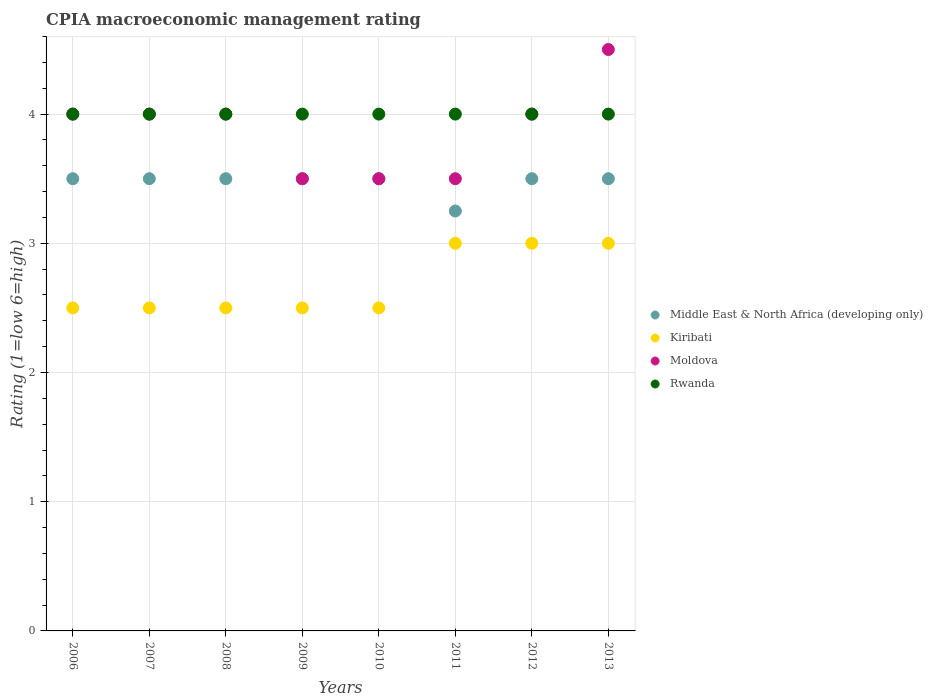How many different coloured dotlines are there?
Provide a short and direct response. 4. Is the number of dotlines equal to the number of legend labels?
Your response must be concise. Yes. What is the CPIA rating in Rwanda in 2010?
Your answer should be compact. 4. Across all years, what is the minimum CPIA rating in Moldova?
Your response must be concise. 3.5. What is the difference between the CPIA rating in Rwanda in 2006 and that in 2009?
Make the answer very short. 0. What is the average CPIA rating in Moldova per year?
Provide a succinct answer. 3.88. In the year 2010, what is the difference between the CPIA rating in Middle East & North Africa (developing only) and CPIA rating in Kiribati?
Your answer should be compact. 1. In how many years, is the CPIA rating in Middle East & North Africa (developing only) greater than 3.4?
Make the answer very short. 7. What is the ratio of the CPIA rating in Moldova in 2009 to that in 2013?
Offer a very short reply. 0.78. Is the CPIA rating in Moldova in 2006 less than that in 2009?
Your answer should be compact. No. What is the difference between the highest and the lowest CPIA rating in Rwanda?
Offer a very short reply. 0. In how many years, is the CPIA rating in Kiribati greater than the average CPIA rating in Kiribati taken over all years?
Make the answer very short. 3. Is the sum of the CPIA rating in Kiribati in 2008 and 2011 greater than the maximum CPIA rating in Moldova across all years?
Give a very brief answer. Yes. Is it the case that in every year, the sum of the CPIA rating in Middle East & North Africa (developing only) and CPIA rating in Kiribati  is greater than the sum of CPIA rating in Rwanda and CPIA rating in Moldova?
Ensure brevity in your answer.  Yes. Does the CPIA rating in Middle East & North Africa (developing only) monotonically increase over the years?
Ensure brevity in your answer.  No. Is the CPIA rating in Rwanda strictly greater than the CPIA rating in Moldova over the years?
Ensure brevity in your answer.  No. What is the difference between two consecutive major ticks on the Y-axis?
Keep it short and to the point. 1. Are the values on the major ticks of Y-axis written in scientific E-notation?
Provide a succinct answer. No. Does the graph contain any zero values?
Your response must be concise. No. Where does the legend appear in the graph?
Your answer should be very brief. Center right. How many legend labels are there?
Offer a terse response. 4. How are the legend labels stacked?
Provide a short and direct response. Vertical. What is the title of the graph?
Offer a terse response. CPIA macroeconomic management rating. Does "Uganda" appear as one of the legend labels in the graph?
Your answer should be very brief. No. What is the label or title of the X-axis?
Offer a very short reply. Years. What is the Rating (1=low 6=high) in Middle East & North Africa (developing only) in 2006?
Provide a succinct answer. 3.5. What is the Rating (1=low 6=high) in Rwanda in 2006?
Keep it short and to the point. 4. What is the Rating (1=low 6=high) of Middle East & North Africa (developing only) in 2007?
Ensure brevity in your answer.  3.5. What is the Rating (1=low 6=high) of Kiribati in 2007?
Your response must be concise. 2.5. What is the Rating (1=low 6=high) of Moldova in 2007?
Offer a very short reply. 4. What is the Rating (1=low 6=high) in Middle East & North Africa (developing only) in 2008?
Your answer should be very brief. 3.5. What is the Rating (1=low 6=high) in Kiribati in 2008?
Provide a short and direct response. 2.5. What is the Rating (1=low 6=high) of Kiribati in 2009?
Give a very brief answer. 2.5. What is the Rating (1=low 6=high) of Kiribati in 2010?
Provide a succinct answer. 2.5. What is the Rating (1=low 6=high) of Rwanda in 2010?
Give a very brief answer. 4. What is the Rating (1=low 6=high) of Moldova in 2011?
Your response must be concise. 3.5. What is the Rating (1=low 6=high) of Rwanda in 2011?
Your answer should be compact. 4. What is the Rating (1=low 6=high) of Rwanda in 2012?
Provide a short and direct response. 4. What is the Rating (1=low 6=high) of Rwanda in 2013?
Your response must be concise. 4. Across all years, what is the maximum Rating (1=low 6=high) of Kiribati?
Provide a short and direct response. 3. Across all years, what is the minimum Rating (1=low 6=high) of Middle East & North Africa (developing only)?
Provide a succinct answer. 3.25. Across all years, what is the minimum Rating (1=low 6=high) in Rwanda?
Ensure brevity in your answer.  4. What is the total Rating (1=low 6=high) in Middle East & North Africa (developing only) in the graph?
Provide a short and direct response. 27.75. What is the total Rating (1=low 6=high) in Kiribati in the graph?
Your response must be concise. 21.5. What is the total Rating (1=low 6=high) of Rwanda in the graph?
Provide a short and direct response. 32. What is the difference between the Rating (1=low 6=high) in Middle East & North Africa (developing only) in 2006 and that in 2007?
Offer a terse response. 0. What is the difference between the Rating (1=low 6=high) in Middle East & North Africa (developing only) in 2006 and that in 2008?
Offer a very short reply. 0. What is the difference between the Rating (1=low 6=high) in Moldova in 2006 and that in 2008?
Give a very brief answer. 0. What is the difference between the Rating (1=low 6=high) in Rwanda in 2006 and that in 2008?
Give a very brief answer. 0. What is the difference between the Rating (1=low 6=high) of Middle East & North Africa (developing only) in 2006 and that in 2009?
Offer a very short reply. 0. What is the difference between the Rating (1=low 6=high) in Moldova in 2006 and that in 2009?
Provide a succinct answer. 0.5. What is the difference between the Rating (1=low 6=high) of Rwanda in 2006 and that in 2009?
Offer a very short reply. 0. What is the difference between the Rating (1=low 6=high) of Middle East & North Africa (developing only) in 2006 and that in 2010?
Offer a very short reply. 0. What is the difference between the Rating (1=low 6=high) of Kiribati in 2006 and that in 2010?
Offer a terse response. 0. What is the difference between the Rating (1=low 6=high) in Rwanda in 2006 and that in 2010?
Provide a short and direct response. 0. What is the difference between the Rating (1=low 6=high) of Moldova in 2006 and that in 2011?
Offer a terse response. 0.5. What is the difference between the Rating (1=low 6=high) of Rwanda in 2006 and that in 2011?
Provide a succinct answer. 0. What is the difference between the Rating (1=low 6=high) in Middle East & North Africa (developing only) in 2006 and that in 2013?
Provide a succinct answer. 0. What is the difference between the Rating (1=low 6=high) in Kiribati in 2006 and that in 2013?
Ensure brevity in your answer.  -0.5. What is the difference between the Rating (1=low 6=high) of Moldova in 2006 and that in 2013?
Give a very brief answer. -0.5. What is the difference between the Rating (1=low 6=high) of Rwanda in 2006 and that in 2013?
Offer a terse response. 0. What is the difference between the Rating (1=low 6=high) of Rwanda in 2007 and that in 2008?
Offer a very short reply. 0. What is the difference between the Rating (1=low 6=high) in Kiribati in 2007 and that in 2009?
Provide a succinct answer. 0. What is the difference between the Rating (1=low 6=high) of Moldova in 2007 and that in 2009?
Offer a terse response. 0.5. What is the difference between the Rating (1=low 6=high) in Rwanda in 2007 and that in 2009?
Your response must be concise. 0. What is the difference between the Rating (1=low 6=high) of Middle East & North Africa (developing only) in 2007 and that in 2010?
Ensure brevity in your answer.  0. What is the difference between the Rating (1=low 6=high) of Kiribati in 2007 and that in 2010?
Give a very brief answer. 0. What is the difference between the Rating (1=low 6=high) of Moldova in 2007 and that in 2011?
Your answer should be very brief. 0.5. What is the difference between the Rating (1=low 6=high) in Kiribati in 2007 and that in 2012?
Offer a very short reply. -0.5. What is the difference between the Rating (1=low 6=high) in Rwanda in 2007 and that in 2012?
Give a very brief answer. 0. What is the difference between the Rating (1=low 6=high) in Rwanda in 2007 and that in 2013?
Offer a terse response. 0. What is the difference between the Rating (1=low 6=high) of Middle East & North Africa (developing only) in 2008 and that in 2009?
Your response must be concise. 0. What is the difference between the Rating (1=low 6=high) in Moldova in 2008 and that in 2009?
Your answer should be very brief. 0.5. What is the difference between the Rating (1=low 6=high) of Kiribati in 2008 and that in 2010?
Your response must be concise. 0. What is the difference between the Rating (1=low 6=high) in Middle East & North Africa (developing only) in 2008 and that in 2011?
Offer a terse response. 0.25. What is the difference between the Rating (1=low 6=high) in Kiribati in 2008 and that in 2011?
Provide a succinct answer. -0.5. What is the difference between the Rating (1=low 6=high) of Middle East & North Africa (developing only) in 2008 and that in 2012?
Provide a short and direct response. 0. What is the difference between the Rating (1=low 6=high) in Kiribati in 2008 and that in 2013?
Offer a very short reply. -0.5. What is the difference between the Rating (1=low 6=high) in Moldova in 2008 and that in 2013?
Your answer should be very brief. -0.5. What is the difference between the Rating (1=low 6=high) in Moldova in 2009 and that in 2011?
Give a very brief answer. 0. What is the difference between the Rating (1=low 6=high) of Middle East & North Africa (developing only) in 2009 and that in 2012?
Your answer should be compact. 0. What is the difference between the Rating (1=low 6=high) of Moldova in 2009 and that in 2012?
Provide a short and direct response. -0.5. What is the difference between the Rating (1=low 6=high) of Kiribati in 2009 and that in 2013?
Ensure brevity in your answer.  -0.5. What is the difference between the Rating (1=low 6=high) in Moldova in 2009 and that in 2013?
Offer a terse response. -1. What is the difference between the Rating (1=low 6=high) of Rwanda in 2009 and that in 2013?
Keep it short and to the point. 0. What is the difference between the Rating (1=low 6=high) in Kiribati in 2010 and that in 2011?
Give a very brief answer. -0.5. What is the difference between the Rating (1=low 6=high) in Moldova in 2010 and that in 2011?
Provide a short and direct response. 0. What is the difference between the Rating (1=low 6=high) in Middle East & North Africa (developing only) in 2010 and that in 2012?
Make the answer very short. 0. What is the difference between the Rating (1=low 6=high) of Kiribati in 2010 and that in 2012?
Offer a very short reply. -0.5. What is the difference between the Rating (1=low 6=high) in Middle East & North Africa (developing only) in 2010 and that in 2013?
Ensure brevity in your answer.  0. What is the difference between the Rating (1=low 6=high) in Kiribati in 2010 and that in 2013?
Your answer should be compact. -0.5. What is the difference between the Rating (1=low 6=high) of Moldova in 2010 and that in 2013?
Keep it short and to the point. -1. What is the difference between the Rating (1=low 6=high) of Rwanda in 2010 and that in 2013?
Ensure brevity in your answer.  0. What is the difference between the Rating (1=low 6=high) in Middle East & North Africa (developing only) in 2011 and that in 2012?
Offer a very short reply. -0.25. What is the difference between the Rating (1=low 6=high) in Moldova in 2011 and that in 2012?
Your answer should be compact. -0.5. What is the difference between the Rating (1=low 6=high) of Middle East & North Africa (developing only) in 2011 and that in 2013?
Make the answer very short. -0.25. What is the difference between the Rating (1=low 6=high) in Rwanda in 2011 and that in 2013?
Keep it short and to the point. 0. What is the difference between the Rating (1=low 6=high) in Middle East & North Africa (developing only) in 2012 and that in 2013?
Offer a terse response. 0. What is the difference between the Rating (1=low 6=high) of Kiribati in 2012 and that in 2013?
Ensure brevity in your answer.  0. What is the difference between the Rating (1=low 6=high) of Rwanda in 2012 and that in 2013?
Offer a very short reply. 0. What is the difference between the Rating (1=low 6=high) in Middle East & North Africa (developing only) in 2006 and the Rating (1=low 6=high) in Moldova in 2007?
Ensure brevity in your answer.  -0.5. What is the difference between the Rating (1=low 6=high) in Kiribati in 2006 and the Rating (1=low 6=high) in Rwanda in 2007?
Provide a succinct answer. -1.5. What is the difference between the Rating (1=low 6=high) of Middle East & North Africa (developing only) in 2006 and the Rating (1=low 6=high) of Moldova in 2008?
Offer a very short reply. -0.5. What is the difference between the Rating (1=low 6=high) in Middle East & North Africa (developing only) in 2006 and the Rating (1=low 6=high) in Rwanda in 2008?
Ensure brevity in your answer.  -0.5. What is the difference between the Rating (1=low 6=high) of Kiribati in 2006 and the Rating (1=low 6=high) of Moldova in 2008?
Make the answer very short. -1.5. What is the difference between the Rating (1=low 6=high) in Kiribati in 2006 and the Rating (1=low 6=high) in Rwanda in 2009?
Your answer should be compact. -1.5. What is the difference between the Rating (1=low 6=high) in Middle East & North Africa (developing only) in 2006 and the Rating (1=low 6=high) in Kiribati in 2010?
Offer a very short reply. 1. What is the difference between the Rating (1=low 6=high) of Kiribati in 2006 and the Rating (1=low 6=high) of Rwanda in 2010?
Offer a very short reply. -1.5. What is the difference between the Rating (1=low 6=high) in Middle East & North Africa (developing only) in 2006 and the Rating (1=low 6=high) in Kiribati in 2011?
Keep it short and to the point. 0.5. What is the difference between the Rating (1=low 6=high) of Middle East & North Africa (developing only) in 2006 and the Rating (1=low 6=high) of Moldova in 2011?
Offer a terse response. 0. What is the difference between the Rating (1=low 6=high) of Kiribati in 2006 and the Rating (1=low 6=high) of Moldova in 2011?
Ensure brevity in your answer.  -1. What is the difference between the Rating (1=low 6=high) in Middle East & North Africa (developing only) in 2006 and the Rating (1=low 6=high) in Kiribati in 2012?
Offer a very short reply. 0.5. What is the difference between the Rating (1=low 6=high) of Middle East & North Africa (developing only) in 2006 and the Rating (1=low 6=high) of Moldova in 2012?
Offer a very short reply. -0.5. What is the difference between the Rating (1=low 6=high) in Middle East & North Africa (developing only) in 2006 and the Rating (1=low 6=high) in Rwanda in 2012?
Offer a terse response. -0.5. What is the difference between the Rating (1=low 6=high) of Kiribati in 2006 and the Rating (1=low 6=high) of Moldova in 2012?
Provide a short and direct response. -1.5. What is the difference between the Rating (1=low 6=high) of Kiribati in 2006 and the Rating (1=low 6=high) of Rwanda in 2012?
Ensure brevity in your answer.  -1.5. What is the difference between the Rating (1=low 6=high) of Middle East & North Africa (developing only) in 2006 and the Rating (1=low 6=high) of Kiribati in 2013?
Ensure brevity in your answer.  0.5. What is the difference between the Rating (1=low 6=high) of Kiribati in 2006 and the Rating (1=low 6=high) of Rwanda in 2013?
Provide a succinct answer. -1.5. What is the difference between the Rating (1=low 6=high) in Moldova in 2006 and the Rating (1=low 6=high) in Rwanda in 2013?
Keep it short and to the point. 0. What is the difference between the Rating (1=low 6=high) in Middle East & North Africa (developing only) in 2007 and the Rating (1=low 6=high) in Kiribati in 2008?
Give a very brief answer. 1. What is the difference between the Rating (1=low 6=high) in Middle East & North Africa (developing only) in 2007 and the Rating (1=low 6=high) in Moldova in 2008?
Provide a short and direct response. -0.5. What is the difference between the Rating (1=low 6=high) in Kiribati in 2007 and the Rating (1=low 6=high) in Rwanda in 2008?
Make the answer very short. -1.5. What is the difference between the Rating (1=low 6=high) in Middle East & North Africa (developing only) in 2007 and the Rating (1=low 6=high) in Kiribati in 2009?
Make the answer very short. 1. What is the difference between the Rating (1=low 6=high) of Middle East & North Africa (developing only) in 2007 and the Rating (1=low 6=high) of Rwanda in 2009?
Your answer should be compact. -0.5. What is the difference between the Rating (1=low 6=high) in Kiribati in 2007 and the Rating (1=low 6=high) in Rwanda in 2009?
Offer a terse response. -1.5. What is the difference between the Rating (1=low 6=high) of Moldova in 2007 and the Rating (1=low 6=high) of Rwanda in 2009?
Provide a succinct answer. 0. What is the difference between the Rating (1=low 6=high) of Moldova in 2007 and the Rating (1=low 6=high) of Rwanda in 2010?
Give a very brief answer. 0. What is the difference between the Rating (1=low 6=high) of Middle East & North Africa (developing only) in 2007 and the Rating (1=low 6=high) of Kiribati in 2011?
Your answer should be compact. 0.5. What is the difference between the Rating (1=low 6=high) of Middle East & North Africa (developing only) in 2007 and the Rating (1=low 6=high) of Moldova in 2011?
Ensure brevity in your answer.  0. What is the difference between the Rating (1=low 6=high) of Kiribati in 2007 and the Rating (1=low 6=high) of Rwanda in 2011?
Your answer should be very brief. -1.5. What is the difference between the Rating (1=low 6=high) of Middle East & North Africa (developing only) in 2007 and the Rating (1=low 6=high) of Moldova in 2012?
Give a very brief answer. -0.5. What is the difference between the Rating (1=low 6=high) of Kiribati in 2007 and the Rating (1=low 6=high) of Moldova in 2012?
Offer a very short reply. -1.5. What is the difference between the Rating (1=low 6=high) in Kiribati in 2007 and the Rating (1=low 6=high) in Rwanda in 2012?
Give a very brief answer. -1.5. What is the difference between the Rating (1=low 6=high) of Moldova in 2007 and the Rating (1=low 6=high) of Rwanda in 2012?
Make the answer very short. 0. What is the difference between the Rating (1=low 6=high) in Middle East & North Africa (developing only) in 2007 and the Rating (1=low 6=high) in Moldova in 2013?
Offer a terse response. -1. What is the difference between the Rating (1=low 6=high) in Middle East & North Africa (developing only) in 2007 and the Rating (1=low 6=high) in Rwanda in 2013?
Provide a short and direct response. -0.5. What is the difference between the Rating (1=low 6=high) of Kiribati in 2007 and the Rating (1=low 6=high) of Moldova in 2013?
Ensure brevity in your answer.  -2. What is the difference between the Rating (1=low 6=high) of Kiribati in 2007 and the Rating (1=low 6=high) of Rwanda in 2013?
Offer a terse response. -1.5. What is the difference between the Rating (1=low 6=high) in Middle East & North Africa (developing only) in 2008 and the Rating (1=low 6=high) in Moldova in 2009?
Your answer should be very brief. 0. What is the difference between the Rating (1=low 6=high) in Kiribati in 2008 and the Rating (1=low 6=high) in Moldova in 2009?
Provide a succinct answer. -1. What is the difference between the Rating (1=low 6=high) in Kiribati in 2008 and the Rating (1=low 6=high) in Rwanda in 2009?
Your response must be concise. -1.5. What is the difference between the Rating (1=low 6=high) of Middle East & North Africa (developing only) in 2008 and the Rating (1=low 6=high) of Rwanda in 2010?
Give a very brief answer. -0.5. What is the difference between the Rating (1=low 6=high) in Kiribati in 2008 and the Rating (1=low 6=high) in Rwanda in 2010?
Your answer should be compact. -1.5. What is the difference between the Rating (1=low 6=high) of Middle East & North Africa (developing only) in 2008 and the Rating (1=low 6=high) of Kiribati in 2011?
Your answer should be very brief. 0.5. What is the difference between the Rating (1=low 6=high) in Middle East & North Africa (developing only) in 2008 and the Rating (1=low 6=high) in Moldova in 2011?
Provide a short and direct response. 0. What is the difference between the Rating (1=low 6=high) in Middle East & North Africa (developing only) in 2008 and the Rating (1=low 6=high) in Rwanda in 2011?
Ensure brevity in your answer.  -0.5. What is the difference between the Rating (1=low 6=high) in Kiribati in 2008 and the Rating (1=low 6=high) in Moldova in 2011?
Offer a terse response. -1. What is the difference between the Rating (1=low 6=high) in Moldova in 2008 and the Rating (1=low 6=high) in Rwanda in 2011?
Offer a very short reply. 0. What is the difference between the Rating (1=low 6=high) in Middle East & North Africa (developing only) in 2008 and the Rating (1=low 6=high) in Kiribati in 2012?
Provide a short and direct response. 0.5. What is the difference between the Rating (1=low 6=high) in Middle East & North Africa (developing only) in 2008 and the Rating (1=low 6=high) in Rwanda in 2012?
Offer a very short reply. -0.5. What is the difference between the Rating (1=low 6=high) of Kiribati in 2008 and the Rating (1=low 6=high) of Moldova in 2012?
Your response must be concise. -1.5. What is the difference between the Rating (1=low 6=high) of Middle East & North Africa (developing only) in 2008 and the Rating (1=low 6=high) of Moldova in 2013?
Keep it short and to the point. -1. What is the difference between the Rating (1=low 6=high) in Middle East & North Africa (developing only) in 2009 and the Rating (1=low 6=high) in Kiribati in 2010?
Give a very brief answer. 1. What is the difference between the Rating (1=low 6=high) in Middle East & North Africa (developing only) in 2009 and the Rating (1=low 6=high) in Moldova in 2010?
Provide a succinct answer. 0. What is the difference between the Rating (1=low 6=high) in Kiribati in 2009 and the Rating (1=low 6=high) in Moldova in 2010?
Keep it short and to the point. -1. What is the difference between the Rating (1=low 6=high) of Moldova in 2009 and the Rating (1=low 6=high) of Rwanda in 2010?
Provide a short and direct response. -0.5. What is the difference between the Rating (1=low 6=high) of Middle East & North Africa (developing only) in 2009 and the Rating (1=low 6=high) of Moldova in 2011?
Your answer should be compact. 0. What is the difference between the Rating (1=low 6=high) of Kiribati in 2009 and the Rating (1=low 6=high) of Moldova in 2011?
Offer a very short reply. -1. What is the difference between the Rating (1=low 6=high) in Kiribati in 2009 and the Rating (1=low 6=high) in Rwanda in 2011?
Provide a succinct answer. -1.5. What is the difference between the Rating (1=low 6=high) in Middle East & North Africa (developing only) in 2009 and the Rating (1=low 6=high) in Kiribati in 2012?
Keep it short and to the point. 0.5. What is the difference between the Rating (1=low 6=high) of Kiribati in 2009 and the Rating (1=low 6=high) of Rwanda in 2012?
Give a very brief answer. -1.5. What is the difference between the Rating (1=low 6=high) in Moldova in 2009 and the Rating (1=low 6=high) in Rwanda in 2012?
Make the answer very short. -0.5. What is the difference between the Rating (1=low 6=high) of Middle East & North Africa (developing only) in 2009 and the Rating (1=low 6=high) of Rwanda in 2013?
Your answer should be compact. -0.5. What is the difference between the Rating (1=low 6=high) in Kiribati in 2009 and the Rating (1=low 6=high) in Rwanda in 2013?
Ensure brevity in your answer.  -1.5. What is the difference between the Rating (1=low 6=high) in Moldova in 2009 and the Rating (1=low 6=high) in Rwanda in 2013?
Your response must be concise. -0.5. What is the difference between the Rating (1=low 6=high) of Kiribati in 2010 and the Rating (1=low 6=high) of Moldova in 2011?
Offer a terse response. -1. What is the difference between the Rating (1=low 6=high) in Moldova in 2010 and the Rating (1=low 6=high) in Rwanda in 2011?
Provide a short and direct response. -0.5. What is the difference between the Rating (1=low 6=high) of Kiribati in 2010 and the Rating (1=low 6=high) of Rwanda in 2012?
Provide a short and direct response. -1.5. What is the difference between the Rating (1=low 6=high) of Moldova in 2010 and the Rating (1=low 6=high) of Rwanda in 2012?
Offer a terse response. -0.5. What is the difference between the Rating (1=low 6=high) of Middle East & North Africa (developing only) in 2010 and the Rating (1=low 6=high) of Kiribati in 2013?
Offer a very short reply. 0.5. What is the difference between the Rating (1=low 6=high) of Middle East & North Africa (developing only) in 2010 and the Rating (1=low 6=high) of Moldova in 2013?
Your response must be concise. -1. What is the difference between the Rating (1=low 6=high) of Middle East & North Africa (developing only) in 2011 and the Rating (1=low 6=high) of Kiribati in 2012?
Your answer should be very brief. 0.25. What is the difference between the Rating (1=low 6=high) of Middle East & North Africa (developing only) in 2011 and the Rating (1=low 6=high) of Moldova in 2012?
Offer a terse response. -0.75. What is the difference between the Rating (1=low 6=high) of Middle East & North Africa (developing only) in 2011 and the Rating (1=low 6=high) of Rwanda in 2012?
Ensure brevity in your answer.  -0.75. What is the difference between the Rating (1=low 6=high) in Kiribati in 2011 and the Rating (1=low 6=high) in Moldova in 2012?
Give a very brief answer. -1. What is the difference between the Rating (1=low 6=high) of Middle East & North Africa (developing only) in 2011 and the Rating (1=low 6=high) of Moldova in 2013?
Offer a terse response. -1.25. What is the difference between the Rating (1=low 6=high) of Middle East & North Africa (developing only) in 2011 and the Rating (1=low 6=high) of Rwanda in 2013?
Your answer should be very brief. -0.75. What is the difference between the Rating (1=low 6=high) in Kiribati in 2011 and the Rating (1=low 6=high) in Moldova in 2013?
Offer a terse response. -1.5. What is the difference between the Rating (1=low 6=high) of Kiribati in 2011 and the Rating (1=low 6=high) of Rwanda in 2013?
Provide a succinct answer. -1. What is the difference between the Rating (1=low 6=high) in Middle East & North Africa (developing only) in 2012 and the Rating (1=low 6=high) in Kiribati in 2013?
Your answer should be very brief. 0.5. What is the difference between the Rating (1=low 6=high) in Middle East & North Africa (developing only) in 2012 and the Rating (1=low 6=high) in Moldova in 2013?
Your response must be concise. -1. What is the difference between the Rating (1=low 6=high) of Middle East & North Africa (developing only) in 2012 and the Rating (1=low 6=high) of Rwanda in 2013?
Make the answer very short. -0.5. What is the difference between the Rating (1=low 6=high) of Kiribati in 2012 and the Rating (1=low 6=high) of Rwanda in 2013?
Ensure brevity in your answer.  -1. What is the difference between the Rating (1=low 6=high) in Moldova in 2012 and the Rating (1=low 6=high) in Rwanda in 2013?
Give a very brief answer. 0. What is the average Rating (1=low 6=high) of Middle East & North Africa (developing only) per year?
Keep it short and to the point. 3.47. What is the average Rating (1=low 6=high) in Kiribati per year?
Provide a succinct answer. 2.69. What is the average Rating (1=low 6=high) in Moldova per year?
Offer a terse response. 3.88. In the year 2006, what is the difference between the Rating (1=low 6=high) in Middle East & North Africa (developing only) and Rating (1=low 6=high) in Kiribati?
Make the answer very short. 1. In the year 2006, what is the difference between the Rating (1=low 6=high) in Middle East & North Africa (developing only) and Rating (1=low 6=high) in Moldova?
Provide a short and direct response. -0.5. In the year 2006, what is the difference between the Rating (1=low 6=high) in Middle East & North Africa (developing only) and Rating (1=low 6=high) in Rwanda?
Keep it short and to the point. -0.5. In the year 2006, what is the difference between the Rating (1=low 6=high) in Kiribati and Rating (1=low 6=high) in Moldova?
Your answer should be compact. -1.5. In the year 2006, what is the difference between the Rating (1=low 6=high) of Moldova and Rating (1=low 6=high) of Rwanda?
Provide a succinct answer. 0. In the year 2007, what is the difference between the Rating (1=low 6=high) in Middle East & North Africa (developing only) and Rating (1=low 6=high) in Kiribati?
Your answer should be compact. 1. In the year 2007, what is the difference between the Rating (1=low 6=high) in Middle East & North Africa (developing only) and Rating (1=low 6=high) in Rwanda?
Offer a very short reply. -0.5. In the year 2007, what is the difference between the Rating (1=low 6=high) of Kiribati and Rating (1=low 6=high) of Moldova?
Give a very brief answer. -1.5. In the year 2007, what is the difference between the Rating (1=low 6=high) in Kiribati and Rating (1=low 6=high) in Rwanda?
Offer a very short reply. -1.5. In the year 2007, what is the difference between the Rating (1=low 6=high) in Moldova and Rating (1=low 6=high) in Rwanda?
Make the answer very short. 0. In the year 2008, what is the difference between the Rating (1=low 6=high) of Middle East & North Africa (developing only) and Rating (1=low 6=high) of Kiribati?
Provide a succinct answer. 1. In the year 2008, what is the difference between the Rating (1=low 6=high) of Middle East & North Africa (developing only) and Rating (1=low 6=high) of Moldova?
Give a very brief answer. -0.5. In the year 2008, what is the difference between the Rating (1=low 6=high) in Kiribati and Rating (1=low 6=high) in Moldova?
Your answer should be compact. -1.5. In the year 2009, what is the difference between the Rating (1=low 6=high) in Kiribati and Rating (1=low 6=high) in Moldova?
Make the answer very short. -1. In the year 2009, what is the difference between the Rating (1=low 6=high) of Kiribati and Rating (1=low 6=high) of Rwanda?
Ensure brevity in your answer.  -1.5. In the year 2009, what is the difference between the Rating (1=low 6=high) of Moldova and Rating (1=low 6=high) of Rwanda?
Keep it short and to the point. -0.5. In the year 2010, what is the difference between the Rating (1=low 6=high) of Middle East & North Africa (developing only) and Rating (1=low 6=high) of Kiribati?
Your response must be concise. 1. In the year 2010, what is the difference between the Rating (1=low 6=high) of Middle East & North Africa (developing only) and Rating (1=low 6=high) of Rwanda?
Offer a very short reply. -0.5. In the year 2010, what is the difference between the Rating (1=low 6=high) in Moldova and Rating (1=low 6=high) in Rwanda?
Your answer should be very brief. -0.5. In the year 2011, what is the difference between the Rating (1=low 6=high) of Middle East & North Africa (developing only) and Rating (1=low 6=high) of Rwanda?
Make the answer very short. -0.75. In the year 2011, what is the difference between the Rating (1=low 6=high) in Kiribati and Rating (1=low 6=high) in Moldova?
Provide a short and direct response. -0.5. In the year 2011, what is the difference between the Rating (1=low 6=high) of Moldova and Rating (1=low 6=high) of Rwanda?
Your answer should be very brief. -0.5. In the year 2012, what is the difference between the Rating (1=low 6=high) in Middle East & North Africa (developing only) and Rating (1=low 6=high) in Kiribati?
Provide a succinct answer. 0.5. In the year 2012, what is the difference between the Rating (1=low 6=high) of Kiribati and Rating (1=low 6=high) of Moldova?
Ensure brevity in your answer.  -1. In the year 2013, what is the difference between the Rating (1=low 6=high) of Middle East & North Africa (developing only) and Rating (1=low 6=high) of Kiribati?
Provide a succinct answer. 0.5. In the year 2013, what is the difference between the Rating (1=low 6=high) of Moldova and Rating (1=low 6=high) of Rwanda?
Ensure brevity in your answer.  0.5. What is the ratio of the Rating (1=low 6=high) in Moldova in 2006 to that in 2007?
Make the answer very short. 1. What is the ratio of the Rating (1=low 6=high) in Middle East & North Africa (developing only) in 2006 to that in 2008?
Provide a short and direct response. 1. What is the ratio of the Rating (1=low 6=high) of Kiribati in 2006 to that in 2008?
Keep it short and to the point. 1. What is the ratio of the Rating (1=low 6=high) in Kiribati in 2006 to that in 2009?
Your answer should be compact. 1. What is the ratio of the Rating (1=low 6=high) of Kiribati in 2006 to that in 2010?
Offer a terse response. 1. What is the ratio of the Rating (1=low 6=high) in Middle East & North Africa (developing only) in 2006 to that in 2011?
Make the answer very short. 1.08. What is the ratio of the Rating (1=low 6=high) in Moldova in 2006 to that in 2011?
Provide a succinct answer. 1.14. What is the ratio of the Rating (1=low 6=high) of Middle East & North Africa (developing only) in 2006 to that in 2012?
Keep it short and to the point. 1. What is the ratio of the Rating (1=low 6=high) in Kiribati in 2006 to that in 2012?
Make the answer very short. 0.83. What is the ratio of the Rating (1=low 6=high) of Moldova in 2006 to that in 2012?
Your answer should be compact. 1. What is the ratio of the Rating (1=low 6=high) in Kiribati in 2006 to that in 2013?
Keep it short and to the point. 0.83. What is the ratio of the Rating (1=low 6=high) in Rwanda in 2006 to that in 2013?
Offer a terse response. 1. What is the ratio of the Rating (1=low 6=high) in Middle East & North Africa (developing only) in 2007 to that in 2009?
Your answer should be very brief. 1. What is the ratio of the Rating (1=low 6=high) of Kiribati in 2007 to that in 2009?
Make the answer very short. 1. What is the ratio of the Rating (1=low 6=high) in Moldova in 2007 to that in 2009?
Provide a succinct answer. 1.14. What is the ratio of the Rating (1=low 6=high) of Middle East & North Africa (developing only) in 2007 to that in 2010?
Provide a short and direct response. 1. What is the ratio of the Rating (1=low 6=high) of Moldova in 2007 to that in 2010?
Offer a terse response. 1.14. What is the ratio of the Rating (1=low 6=high) in Rwanda in 2007 to that in 2010?
Your response must be concise. 1. What is the ratio of the Rating (1=low 6=high) of Moldova in 2007 to that in 2011?
Keep it short and to the point. 1.14. What is the ratio of the Rating (1=low 6=high) in Middle East & North Africa (developing only) in 2007 to that in 2012?
Ensure brevity in your answer.  1. What is the ratio of the Rating (1=low 6=high) in Moldova in 2007 to that in 2012?
Your answer should be very brief. 1. What is the ratio of the Rating (1=low 6=high) of Moldova in 2008 to that in 2009?
Provide a succinct answer. 1.14. What is the ratio of the Rating (1=low 6=high) of Rwanda in 2008 to that in 2009?
Provide a succinct answer. 1. What is the ratio of the Rating (1=low 6=high) in Middle East & North Africa (developing only) in 2008 to that in 2010?
Ensure brevity in your answer.  1. What is the ratio of the Rating (1=low 6=high) of Kiribati in 2008 to that in 2011?
Provide a succinct answer. 0.83. What is the ratio of the Rating (1=low 6=high) of Rwanda in 2008 to that in 2011?
Give a very brief answer. 1. What is the ratio of the Rating (1=low 6=high) in Middle East & North Africa (developing only) in 2008 to that in 2012?
Make the answer very short. 1. What is the ratio of the Rating (1=low 6=high) in Kiribati in 2008 to that in 2012?
Ensure brevity in your answer.  0.83. What is the ratio of the Rating (1=low 6=high) of Rwanda in 2008 to that in 2012?
Keep it short and to the point. 1. What is the ratio of the Rating (1=low 6=high) in Moldova in 2008 to that in 2013?
Keep it short and to the point. 0.89. What is the ratio of the Rating (1=low 6=high) of Rwanda in 2008 to that in 2013?
Make the answer very short. 1. What is the ratio of the Rating (1=low 6=high) of Middle East & North Africa (developing only) in 2009 to that in 2010?
Your answer should be compact. 1. What is the ratio of the Rating (1=low 6=high) in Kiribati in 2009 to that in 2010?
Make the answer very short. 1. What is the ratio of the Rating (1=low 6=high) in Rwanda in 2009 to that in 2010?
Provide a short and direct response. 1. What is the ratio of the Rating (1=low 6=high) of Moldova in 2009 to that in 2011?
Your response must be concise. 1. What is the ratio of the Rating (1=low 6=high) of Rwanda in 2009 to that in 2011?
Make the answer very short. 1. What is the ratio of the Rating (1=low 6=high) of Middle East & North Africa (developing only) in 2009 to that in 2012?
Give a very brief answer. 1. What is the ratio of the Rating (1=low 6=high) of Kiribati in 2009 to that in 2012?
Keep it short and to the point. 0.83. What is the ratio of the Rating (1=low 6=high) in Moldova in 2009 to that in 2012?
Your answer should be very brief. 0.88. What is the ratio of the Rating (1=low 6=high) of Kiribati in 2009 to that in 2013?
Your answer should be very brief. 0.83. What is the ratio of the Rating (1=low 6=high) in Moldova in 2010 to that in 2011?
Give a very brief answer. 1. What is the ratio of the Rating (1=low 6=high) in Middle East & North Africa (developing only) in 2010 to that in 2012?
Your answer should be very brief. 1. What is the ratio of the Rating (1=low 6=high) in Kiribati in 2010 to that in 2012?
Keep it short and to the point. 0.83. What is the ratio of the Rating (1=low 6=high) of Moldova in 2010 to that in 2012?
Your answer should be very brief. 0.88. What is the ratio of the Rating (1=low 6=high) in Kiribati in 2010 to that in 2013?
Give a very brief answer. 0.83. What is the ratio of the Rating (1=low 6=high) in Moldova in 2010 to that in 2013?
Give a very brief answer. 0.78. What is the ratio of the Rating (1=low 6=high) in Rwanda in 2010 to that in 2013?
Your answer should be very brief. 1. What is the ratio of the Rating (1=low 6=high) in Middle East & North Africa (developing only) in 2011 to that in 2012?
Provide a short and direct response. 0.93. What is the ratio of the Rating (1=low 6=high) of Kiribati in 2011 to that in 2012?
Offer a terse response. 1. What is the ratio of the Rating (1=low 6=high) of Rwanda in 2011 to that in 2012?
Keep it short and to the point. 1. What is the ratio of the Rating (1=low 6=high) of Middle East & North Africa (developing only) in 2011 to that in 2013?
Your response must be concise. 0.93. What is the ratio of the Rating (1=low 6=high) of Moldova in 2011 to that in 2013?
Ensure brevity in your answer.  0.78. What is the ratio of the Rating (1=low 6=high) of Moldova in 2012 to that in 2013?
Offer a very short reply. 0.89. What is the ratio of the Rating (1=low 6=high) of Rwanda in 2012 to that in 2013?
Make the answer very short. 1. What is the difference between the highest and the lowest Rating (1=low 6=high) in Middle East & North Africa (developing only)?
Your answer should be very brief. 0.25. What is the difference between the highest and the lowest Rating (1=low 6=high) of Moldova?
Provide a succinct answer. 1. 